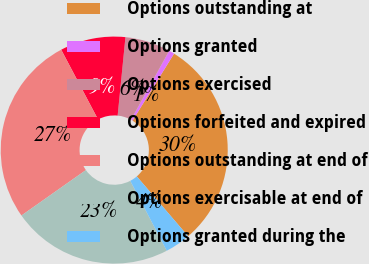Convert chart. <chart><loc_0><loc_0><loc_500><loc_500><pie_chart><fcel>Options outstanding at<fcel>Options granted<fcel>Options exercised<fcel>Options forfeited and expired<fcel>Options outstanding at end of<fcel>Options exercisable at end of<fcel>Options granted during the<nl><fcel>29.88%<fcel>0.79%<fcel>6.47%<fcel>9.31%<fcel>27.04%<fcel>22.88%<fcel>3.63%<nl></chart> 